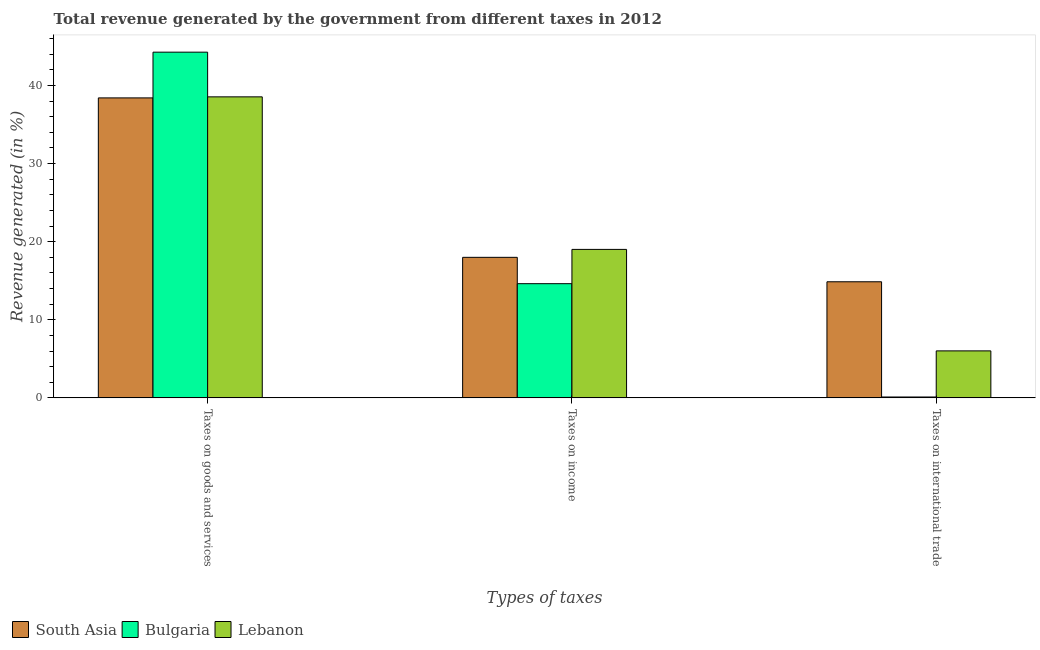How many different coloured bars are there?
Offer a terse response. 3. How many groups of bars are there?
Give a very brief answer. 3. Are the number of bars on each tick of the X-axis equal?
Offer a terse response. Yes. What is the label of the 1st group of bars from the left?
Provide a short and direct response. Taxes on goods and services. What is the percentage of revenue generated by taxes on goods and services in Bulgaria?
Give a very brief answer. 44.27. Across all countries, what is the maximum percentage of revenue generated by taxes on income?
Keep it short and to the point. 19.01. Across all countries, what is the minimum percentage of revenue generated by taxes on goods and services?
Make the answer very short. 38.41. In which country was the percentage of revenue generated by tax on international trade maximum?
Your answer should be very brief. South Asia. What is the total percentage of revenue generated by tax on international trade in the graph?
Give a very brief answer. 21. What is the difference between the percentage of revenue generated by taxes on goods and services in South Asia and that in Bulgaria?
Provide a short and direct response. -5.86. What is the difference between the percentage of revenue generated by taxes on income in South Asia and the percentage of revenue generated by tax on international trade in Lebanon?
Keep it short and to the point. 11.98. What is the average percentage of revenue generated by taxes on goods and services per country?
Offer a very short reply. 40.41. What is the difference between the percentage of revenue generated by tax on international trade and percentage of revenue generated by taxes on income in Bulgaria?
Make the answer very short. -14.51. In how many countries, is the percentage of revenue generated by tax on international trade greater than 40 %?
Your response must be concise. 0. What is the ratio of the percentage of revenue generated by tax on international trade in South Asia to that in Lebanon?
Keep it short and to the point. 2.47. Is the percentage of revenue generated by taxes on income in South Asia less than that in Bulgaria?
Your answer should be compact. No. Is the difference between the percentage of revenue generated by taxes on income in South Asia and Lebanon greater than the difference between the percentage of revenue generated by taxes on goods and services in South Asia and Lebanon?
Ensure brevity in your answer.  No. What is the difference between the highest and the second highest percentage of revenue generated by taxes on goods and services?
Ensure brevity in your answer.  5.72. What is the difference between the highest and the lowest percentage of revenue generated by taxes on goods and services?
Ensure brevity in your answer.  5.86. Is the sum of the percentage of revenue generated by taxes on income in South Asia and Bulgaria greater than the maximum percentage of revenue generated by tax on international trade across all countries?
Make the answer very short. Yes. What does the 3rd bar from the left in Taxes on income represents?
Provide a succinct answer. Lebanon. What does the 1st bar from the right in Taxes on income represents?
Ensure brevity in your answer.  Lebanon. Is it the case that in every country, the sum of the percentage of revenue generated by taxes on goods and services and percentage of revenue generated by taxes on income is greater than the percentage of revenue generated by tax on international trade?
Provide a succinct answer. Yes. What is the difference between two consecutive major ticks on the Y-axis?
Provide a succinct answer. 10. How many legend labels are there?
Your response must be concise. 3. How are the legend labels stacked?
Keep it short and to the point. Horizontal. What is the title of the graph?
Your answer should be very brief. Total revenue generated by the government from different taxes in 2012. Does "Curacao" appear as one of the legend labels in the graph?
Your response must be concise. No. What is the label or title of the X-axis?
Offer a very short reply. Types of taxes. What is the label or title of the Y-axis?
Keep it short and to the point. Revenue generated (in %). What is the Revenue generated (in %) in South Asia in Taxes on goods and services?
Offer a very short reply. 38.41. What is the Revenue generated (in %) in Bulgaria in Taxes on goods and services?
Your answer should be compact. 44.27. What is the Revenue generated (in %) of Lebanon in Taxes on goods and services?
Provide a succinct answer. 38.55. What is the Revenue generated (in %) of South Asia in Taxes on income?
Offer a very short reply. 18. What is the Revenue generated (in %) in Bulgaria in Taxes on income?
Ensure brevity in your answer.  14.62. What is the Revenue generated (in %) in Lebanon in Taxes on income?
Your answer should be compact. 19.01. What is the Revenue generated (in %) in South Asia in Taxes on international trade?
Provide a succinct answer. 14.87. What is the Revenue generated (in %) of Bulgaria in Taxes on international trade?
Ensure brevity in your answer.  0.11. What is the Revenue generated (in %) in Lebanon in Taxes on international trade?
Ensure brevity in your answer.  6.02. Across all Types of taxes, what is the maximum Revenue generated (in %) in South Asia?
Provide a short and direct response. 38.41. Across all Types of taxes, what is the maximum Revenue generated (in %) of Bulgaria?
Provide a succinct answer. 44.27. Across all Types of taxes, what is the maximum Revenue generated (in %) of Lebanon?
Give a very brief answer. 38.55. Across all Types of taxes, what is the minimum Revenue generated (in %) in South Asia?
Offer a very short reply. 14.87. Across all Types of taxes, what is the minimum Revenue generated (in %) of Bulgaria?
Your answer should be very brief. 0.11. Across all Types of taxes, what is the minimum Revenue generated (in %) in Lebanon?
Provide a succinct answer. 6.02. What is the total Revenue generated (in %) in South Asia in the graph?
Offer a very short reply. 71.28. What is the total Revenue generated (in %) of Bulgaria in the graph?
Keep it short and to the point. 59.01. What is the total Revenue generated (in %) of Lebanon in the graph?
Your answer should be very brief. 63.58. What is the difference between the Revenue generated (in %) of South Asia in Taxes on goods and services and that in Taxes on income?
Provide a succinct answer. 20.42. What is the difference between the Revenue generated (in %) of Bulgaria in Taxes on goods and services and that in Taxes on income?
Your answer should be compact. 29.65. What is the difference between the Revenue generated (in %) of Lebanon in Taxes on goods and services and that in Taxes on income?
Ensure brevity in your answer.  19.53. What is the difference between the Revenue generated (in %) of South Asia in Taxes on goods and services and that in Taxes on international trade?
Make the answer very short. 23.55. What is the difference between the Revenue generated (in %) in Bulgaria in Taxes on goods and services and that in Taxes on international trade?
Your response must be concise. 44.16. What is the difference between the Revenue generated (in %) in Lebanon in Taxes on goods and services and that in Taxes on international trade?
Ensure brevity in your answer.  32.53. What is the difference between the Revenue generated (in %) in South Asia in Taxes on income and that in Taxes on international trade?
Your answer should be very brief. 3.13. What is the difference between the Revenue generated (in %) of Bulgaria in Taxes on income and that in Taxes on international trade?
Provide a succinct answer. 14.51. What is the difference between the Revenue generated (in %) in Lebanon in Taxes on income and that in Taxes on international trade?
Ensure brevity in your answer.  13. What is the difference between the Revenue generated (in %) in South Asia in Taxes on goods and services and the Revenue generated (in %) in Bulgaria in Taxes on income?
Your response must be concise. 23.79. What is the difference between the Revenue generated (in %) in South Asia in Taxes on goods and services and the Revenue generated (in %) in Lebanon in Taxes on income?
Your response must be concise. 19.4. What is the difference between the Revenue generated (in %) in Bulgaria in Taxes on goods and services and the Revenue generated (in %) in Lebanon in Taxes on income?
Offer a terse response. 25.26. What is the difference between the Revenue generated (in %) of South Asia in Taxes on goods and services and the Revenue generated (in %) of Bulgaria in Taxes on international trade?
Offer a terse response. 38.3. What is the difference between the Revenue generated (in %) in South Asia in Taxes on goods and services and the Revenue generated (in %) in Lebanon in Taxes on international trade?
Ensure brevity in your answer.  32.4. What is the difference between the Revenue generated (in %) in Bulgaria in Taxes on goods and services and the Revenue generated (in %) in Lebanon in Taxes on international trade?
Offer a terse response. 38.25. What is the difference between the Revenue generated (in %) of South Asia in Taxes on income and the Revenue generated (in %) of Bulgaria in Taxes on international trade?
Make the answer very short. 17.88. What is the difference between the Revenue generated (in %) of South Asia in Taxes on income and the Revenue generated (in %) of Lebanon in Taxes on international trade?
Give a very brief answer. 11.98. What is the difference between the Revenue generated (in %) in Bulgaria in Taxes on income and the Revenue generated (in %) in Lebanon in Taxes on international trade?
Offer a very short reply. 8.61. What is the average Revenue generated (in %) of South Asia per Types of taxes?
Provide a succinct answer. 23.76. What is the average Revenue generated (in %) in Bulgaria per Types of taxes?
Make the answer very short. 19.67. What is the average Revenue generated (in %) in Lebanon per Types of taxes?
Make the answer very short. 21.19. What is the difference between the Revenue generated (in %) in South Asia and Revenue generated (in %) in Bulgaria in Taxes on goods and services?
Offer a very short reply. -5.86. What is the difference between the Revenue generated (in %) of South Asia and Revenue generated (in %) of Lebanon in Taxes on goods and services?
Provide a short and direct response. -0.13. What is the difference between the Revenue generated (in %) in Bulgaria and Revenue generated (in %) in Lebanon in Taxes on goods and services?
Keep it short and to the point. 5.72. What is the difference between the Revenue generated (in %) in South Asia and Revenue generated (in %) in Bulgaria in Taxes on income?
Offer a very short reply. 3.37. What is the difference between the Revenue generated (in %) in South Asia and Revenue generated (in %) in Lebanon in Taxes on income?
Ensure brevity in your answer.  -1.02. What is the difference between the Revenue generated (in %) in Bulgaria and Revenue generated (in %) in Lebanon in Taxes on income?
Make the answer very short. -4.39. What is the difference between the Revenue generated (in %) of South Asia and Revenue generated (in %) of Bulgaria in Taxes on international trade?
Offer a very short reply. 14.75. What is the difference between the Revenue generated (in %) of South Asia and Revenue generated (in %) of Lebanon in Taxes on international trade?
Give a very brief answer. 8.85. What is the difference between the Revenue generated (in %) in Bulgaria and Revenue generated (in %) in Lebanon in Taxes on international trade?
Your response must be concise. -5.9. What is the ratio of the Revenue generated (in %) in South Asia in Taxes on goods and services to that in Taxes on income?
Your answer should be very brief. 2.13. What is the ratio of the Revenue generated (in %) in Bulgaria in Taxes on goods and services to that in Taxes on income?
Offer a very short reply. 3.03. What is the ratio of the Revenue generated (in %) of Lebanon in Taxes on goods and services to that in Taxes on income?
Provide a short and direct response. 2.03. What is the ratio of the Revenue generated (in %) of South Asia in Taxes on goods and services to that in Taxes on international trade?
Provide a succinct answer. 2.58. What is the ratio of the Revenue generated (in %) in Bulgaria in Taxes on goods and services to that in Taxes on international trade?
Provide a succinct answer. 393.5. What is the ratio of the Revenue generated (in %) in Lebanon in Taxes on goods and services to that in Taxes on international trade?
Make the answer very short. 6.41. What is the ratio of the Revenue generated (in %) in South Asia in Taxes on income to that in Taxes on international trade?
Your response must be concise. 1.21. What is the ratio of the Revenue generated (in %) of Bulgaria in Taxes on income to that in Taxes on international trade?
Offer a very short reply. 129.98. What is the ratio of the Revenue generated (in %) in Lebanon in Taxes on income to that in Taxes on international trade?
Provide a short and direct response. 3.16. What is the difference between the highest and the second highest Revenue generated (in %) in South Asia?
Provide a succinct answer. 20.42. What is the difference between the highest and the second highest Revenue generated (in %) in Bulgaria?
Offer a terse response. 29.65. What is the difference between the highest and the second highest Revenue generated (in %) of Lebanon?
Provide a short and direct response. 19.53. What is the difference between the highest and the lowest Revenue generated (in %) in South Asia?
Provide a short and direct response. 23.55. What is the difference between the highest and the lowest Revenue generated (in %) of Bulgaria?
Give a very brief answer. 44.16. What is the difference between the highest and the lowest Revenue generated (in %) in Lebanon?
Give a very brief answer. 32.53. 